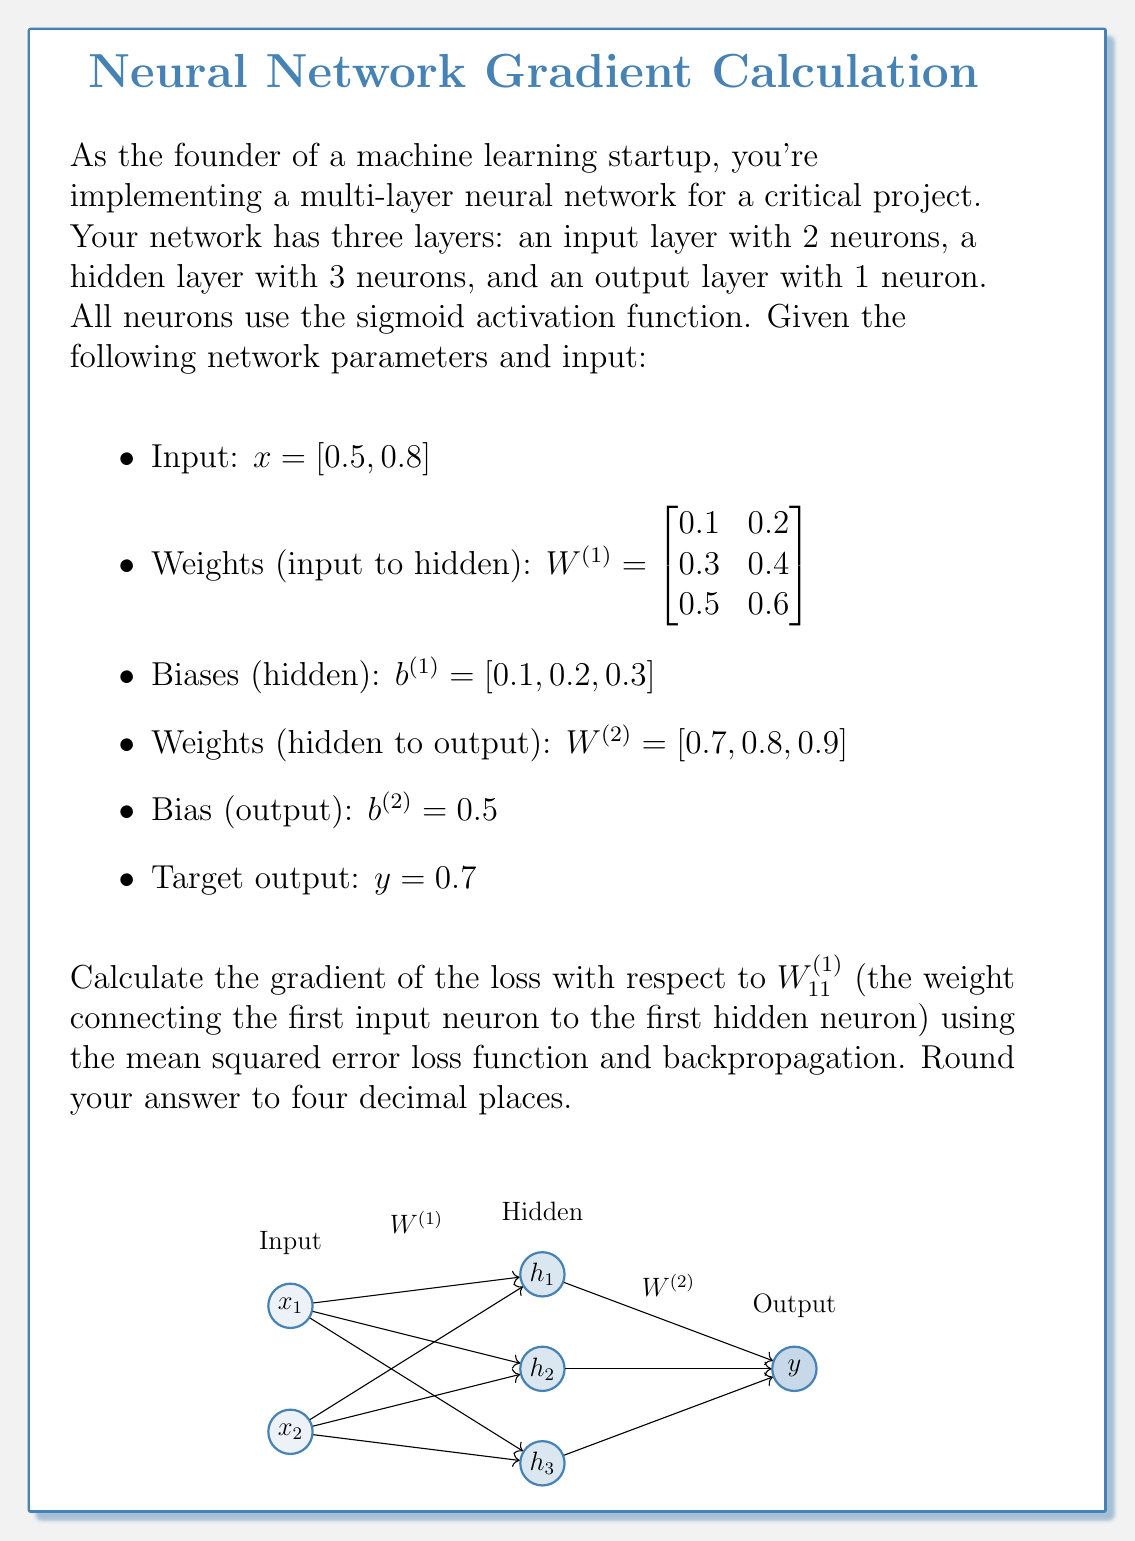Give your solution to this math problem. Let's break this down step-by-step:

1) First, we need to perform forward propagation to get the output:

   Hidden layer activation:
   $$h = \sigma(W^{(1)}x + b^{(1)})$$
   where $\sigma$ is the sigmoid function: $\sigma(z) = \frac{1}{1+e^{-z}}$

   $$h_1 = \sigma(0.1 \cdot 0.5 + 0.2 \cdot 0.8 + 0.1) = \sigma(0.31) = 0.5769$$
   $$h_2 = \sigma(0.3 \cdot 0.5 + 0.4 \cdot 0.8 + 0.2) = \sigma(0.57) = 0.6387$$
   $$h_3 = \sigma(0.5 \cdot 0.5 + 0.6 \cdot 0.8 + 0.3) = \sigma(0.83) = 0.6964$$

   Output layer activation:
   $$\hat{y} = \sigma(W^{(2)}h + b^{(2)})$$
   $$\hat{y} = \sigma(0.7 \cdot 0.5769 + 0.8 \cdot 0.6387 + 0.9 \cdot 0.6964 + 0.5)$$
   $$\hat{y} = \sigma(1.9492) = 0.8754$$

2) Now, we calculate the loss using mean squared error:
   $$L = \frac{1}{2}(y - \hat{y})^2 = \frac{1}{2}(0.7 - 0.8754)^2 = 0.0154$$

3) Next, we perform backpropagation:

   Output layer error:
   $$\delta^{(2)} = (\hat{y} - y) \cdot \hat{y}(1-\hat{y}) = 0.1754 \cdot 0.8754 \cdot 0.1246 = 0.0191$$

   Hidden layer error:
   $$\delta^{(1)} = (W^{(2)})^T \delta^{(2)} \odot h(1-h)$$
   $$\delta^{(1)}_1 = 0.7 \cdot 0.0191 \cdot 0.5769 \cdot 0.4231 = 0.0033$$
   $$\delta^{(1)}_2 = 0.8 \cdot 0.0191 \cdot 0.6387 \cdot 0.3613 = 0.0035$$
   $$\delta^{(1)}_3 = 0.9 \cdot 0.0191 \cdot 0.6964 \cdot 0.3036 = 0.0036$$

4) Finally, we calculate the gradient with respect to $W^{(1)}_{11}$:
   $$\frac{\partial L}{\partial W^{(1)}_{11}} = \delta^{(1)}_1 \cdot x_1 = 0.0033 \cdot 0.5 = 0.0017$$

Rounding to four decimal places, we get 0.0017.
Answer: 0.0017 